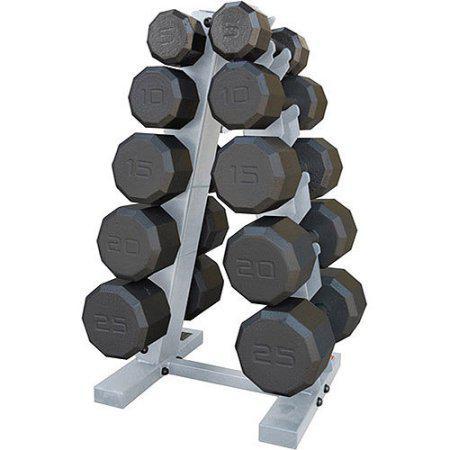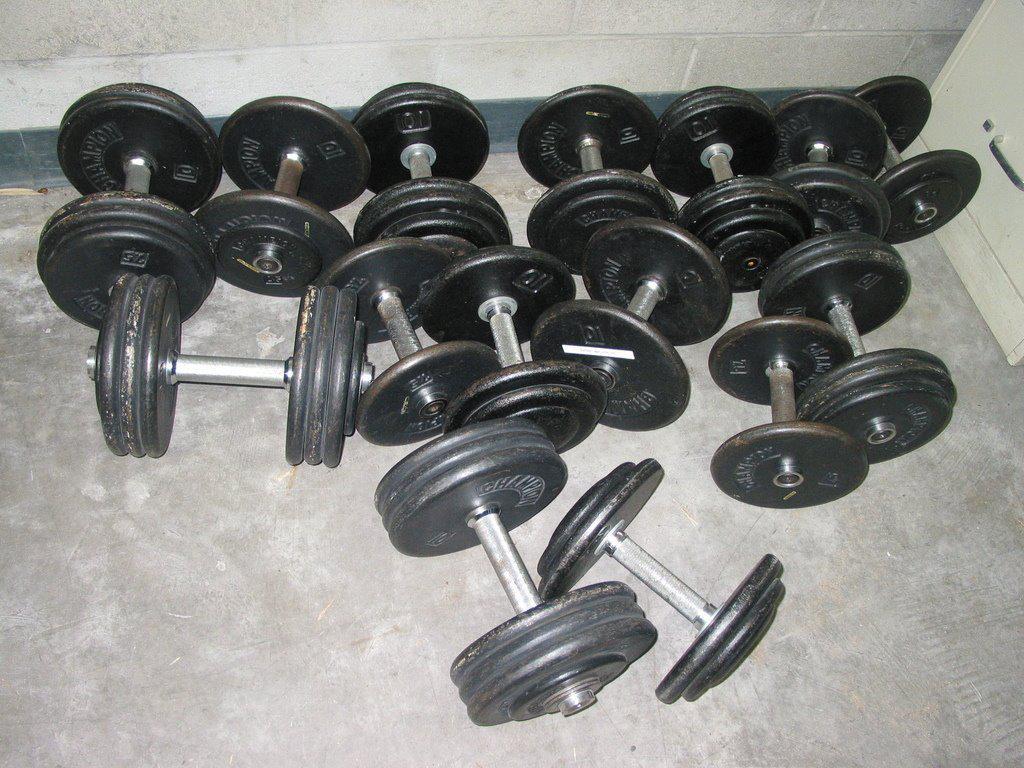The first image is the image on the left, the second image is the image on the right. Evaluate the accuracy of this statement regarding the images: "Each image contains at least ten black dumbbells, and at least one image shows dumbbells stored on a rack.". Is it true? Answer yes or no. Yes. The first image is the image on the left, the second image is the image on the right. Examine the images to the left and right. Is the description "In at least one image there is a bar for a bench that has no weights on it." accurate? Answer yes or no. No. 